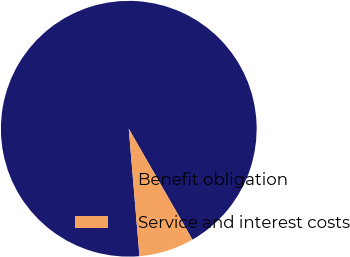Convert chart. <chart><loc_0><loc_0><loc_500><loc_500><pie_chart><fcel>Benefit obligation<fcel>Service and interest costs<nl><fcel>93.04%<fcel>6.96%<nl></chart> 